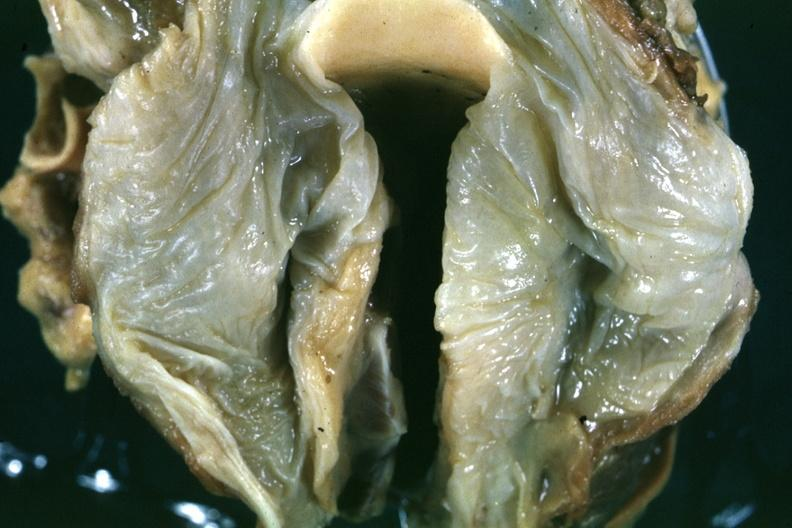what is slide in natural color of the edematous mucosal membrane?
Answer the question using a single word or phrase. A close-up 